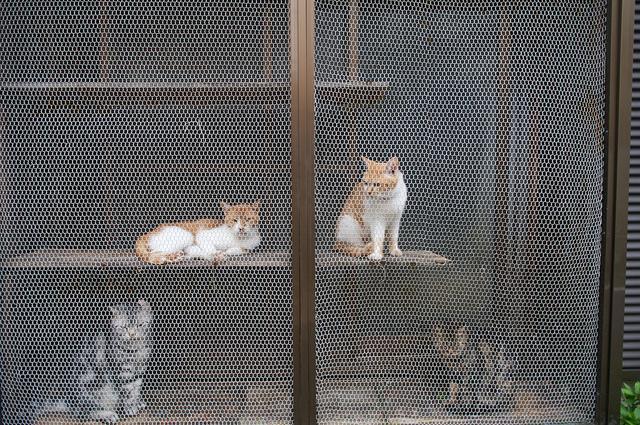How many of the animals are sitting?
Give a very brief answer. 3. How many are white and orange?
Give a very brief answer. 2. How many cats are there?
Give a very brief answer. 4. 